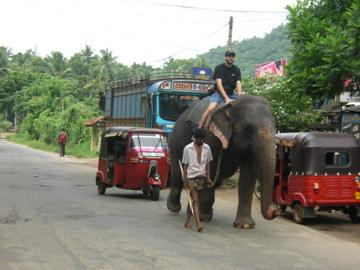The white man is most likely what? tourist 